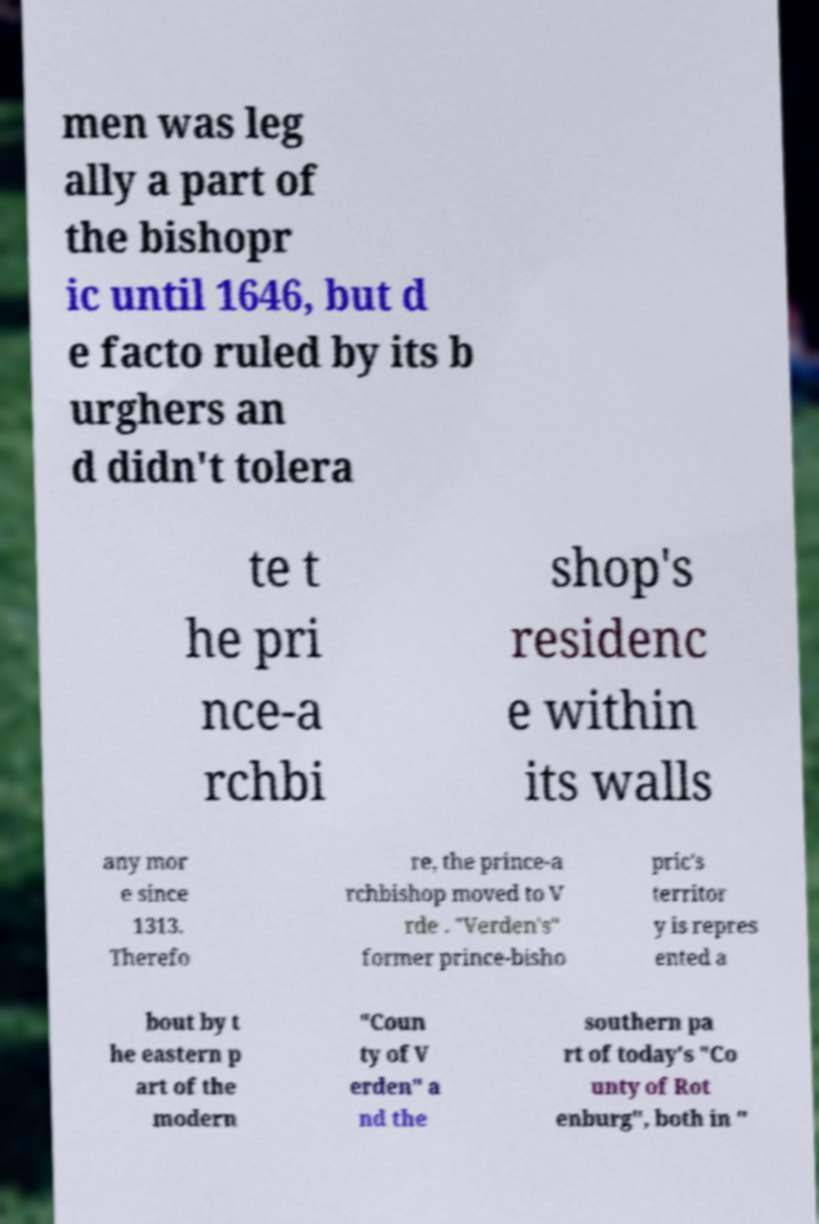Could you extract and type out the text from this image? men was leg ally a part of the bishopr ic until 1646, but d e facto ruled by its b urghers an d didn't tolera te t he pri nce-a rchbi shop's residenc e within its walls any mor e since 1313. Therefo re, the prince-a rchbishop moved to V rde . "Verden's" former prince-bisho pric's territor y is repres ented a bout by t he eastern p art of the modern "Coun ty of V erden" a nd the southern pa rt of today's "Co unty of Rot enburg", both in " 